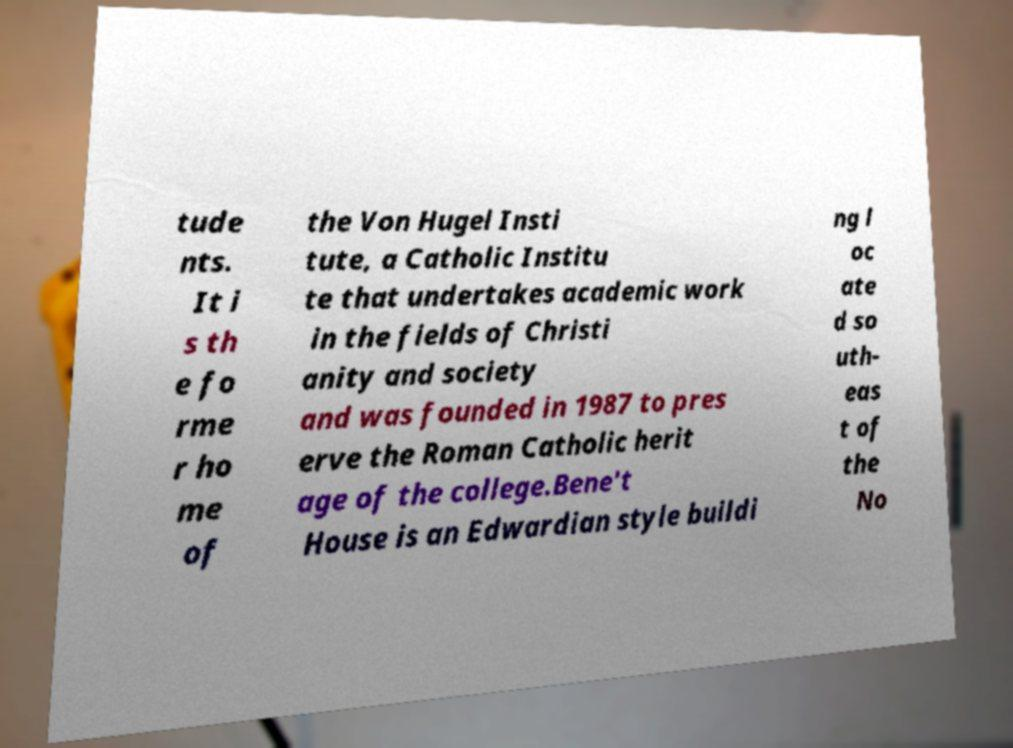Please read and relay the text visible in this image. What does it say? tude nts. It i s th e fo rme r ho me of the Von Hugel Insti tute, a Catholic Institu te that undertakes academic work in the fields of Christi anity and society and was founded in 1987 to pres erve the Roman Catholic herit age of the college.Bene't House is an Edwardian style buildi ng l oc ate d so uth- eas t of the No 